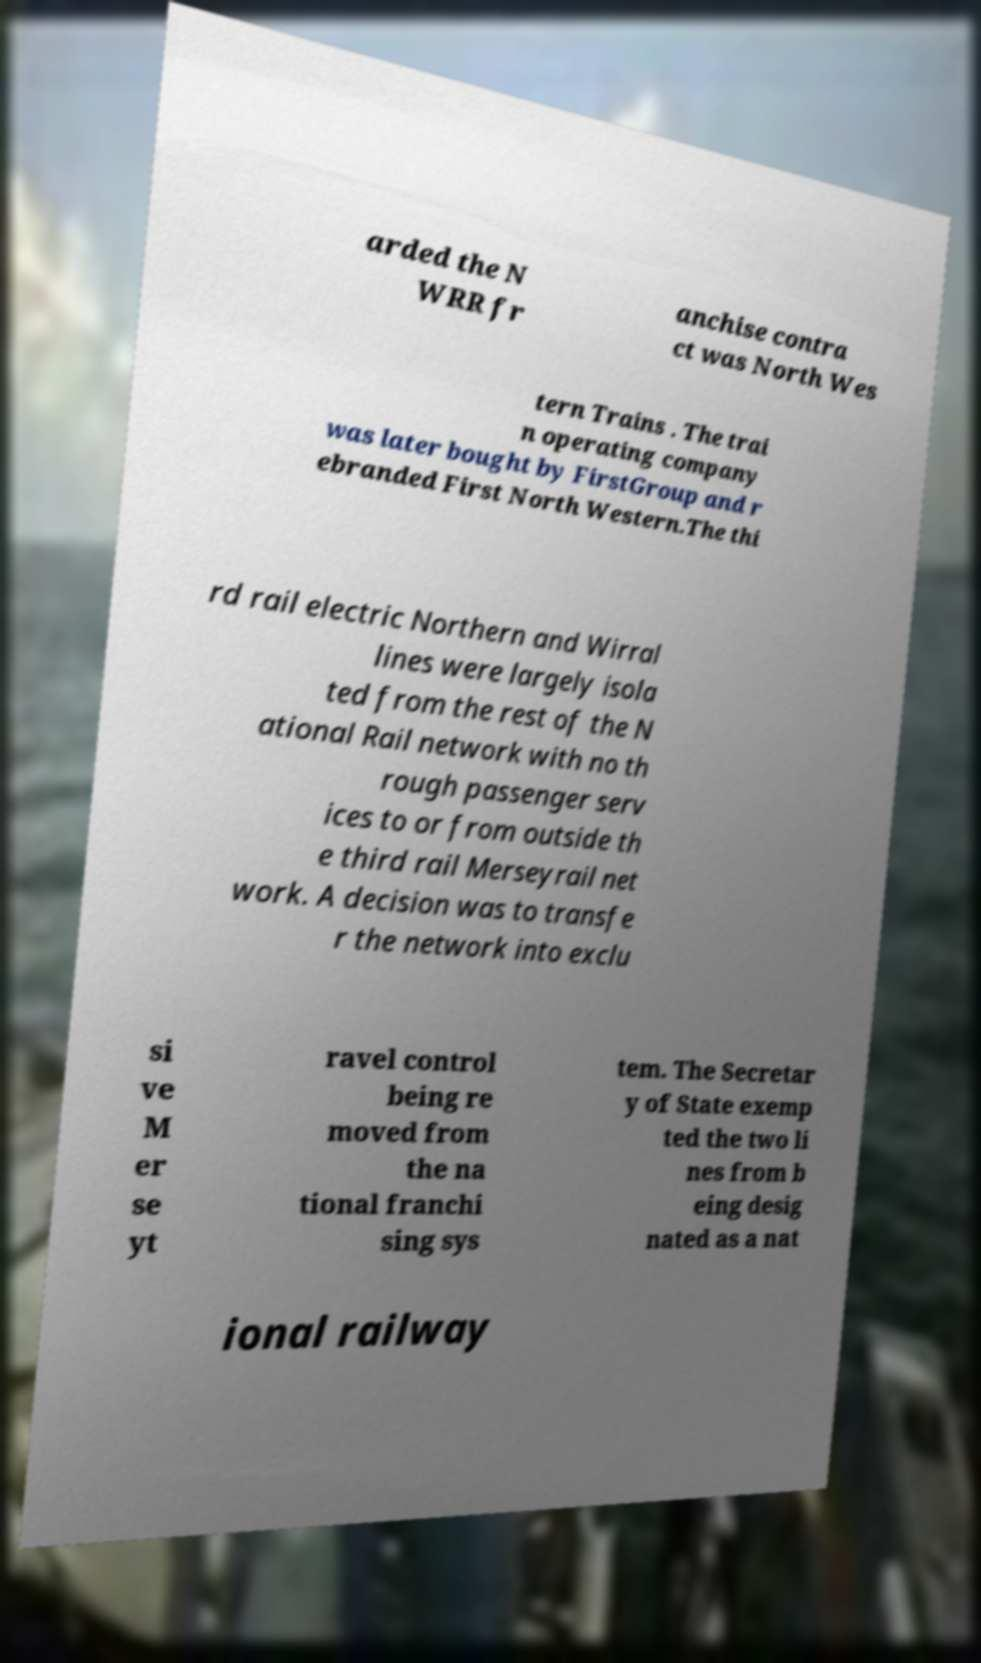For documentation purposes, I need the text within this image transcribed. Could you provide that? arded the N WRR fr anchise contra ct was North Wes tern Trains . The trai n operating company was later bought by FirstGroup and r ebranded First North Western.The thi rd rail electric Northern and Wirral lines were largely isola ted from the rest of the N ational Rail network with no th rough passenger serv ices to or from outside th e third rail Merseyrail net work. A decision was to transfe r the network into exclu si ve M er se yt ravel control being re moved from the na tional franchi sing sys tem. The Secretar y of State exemp ted the two li nes from b eing desig nated as a nat ional railway 